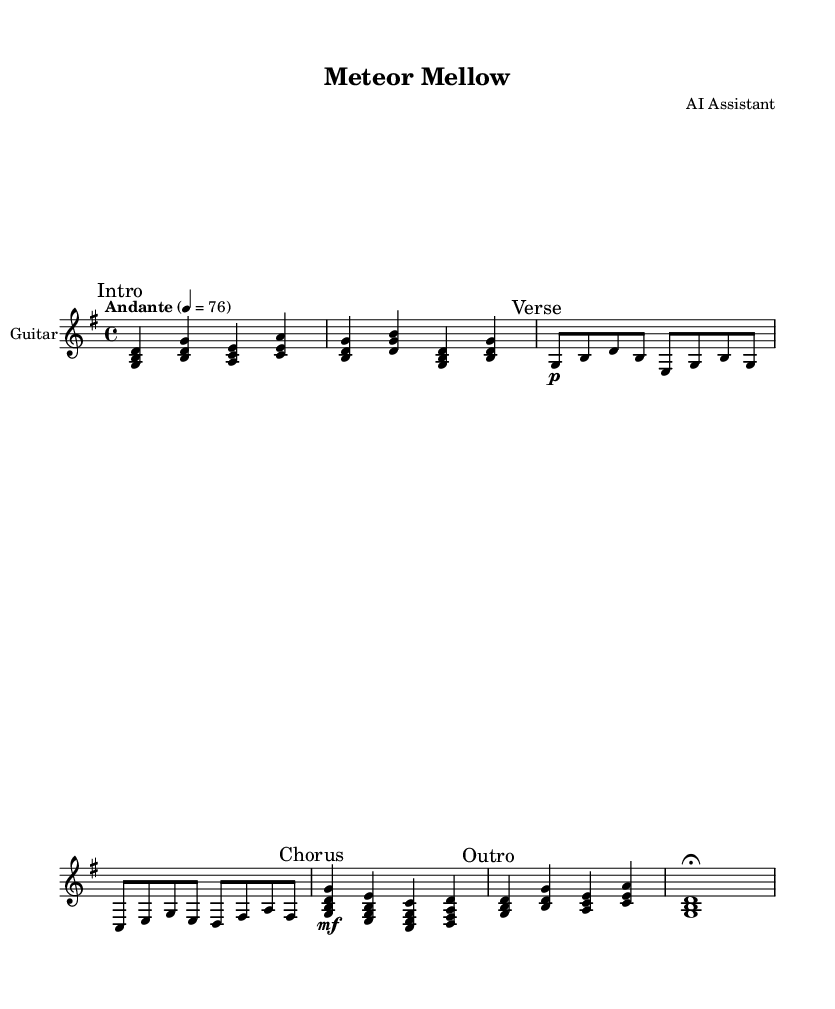What is the key signature of this music? The key signature is G major, which has one sharp (F#). You can determine this by looking at the beginning of the music sheet where the key signature is indicated next to the clef.
Answer: G major What is the time signature of this piece? The time signature is 4/4, indicated at the beginning of the music sheet next to the key signature. This means there are four beats in each measure, and a quarter note receives one beat.
Answer: 4/4 What is the tempo marking provided in the sheet music? The tempo marking is Andante, which suggests a moderately slow tempo, often interpreted to be around 76 beats per minute. This can be found in the header section of the sheet music where the tempo indication is provided.
Answer: Andante How many sections are there in this composition? The composition has four sections: Intro, Verse, Chorus, and Outro. Each section is marked explicitly in the music, making it easy to identify the structure of the piece.
Answer: Four What is the dynamic marking at the beginning of the Verse? The dynamic marking at the beginning of the Verse is piano (p), which indicates that this part should be played softly. This marking helps musicians understand how to approach the performance of that particular section.
Answer: piano What is the primary instrument for this score? The primary instrument is the guitar, specified in the staff settings where it states "instrumentName = 'Guitar'." This indicates that the piece is written for guitar performance.
Answer: Guitar What type of guitar is specified for the MIDI instrument? The MIDI instrument specified is an acoustic guitar (nylon). This detail is included in the score setup, indicating the intended sound for the electronic playback of the music.
Answer: Acoustic guitar (nylon) 